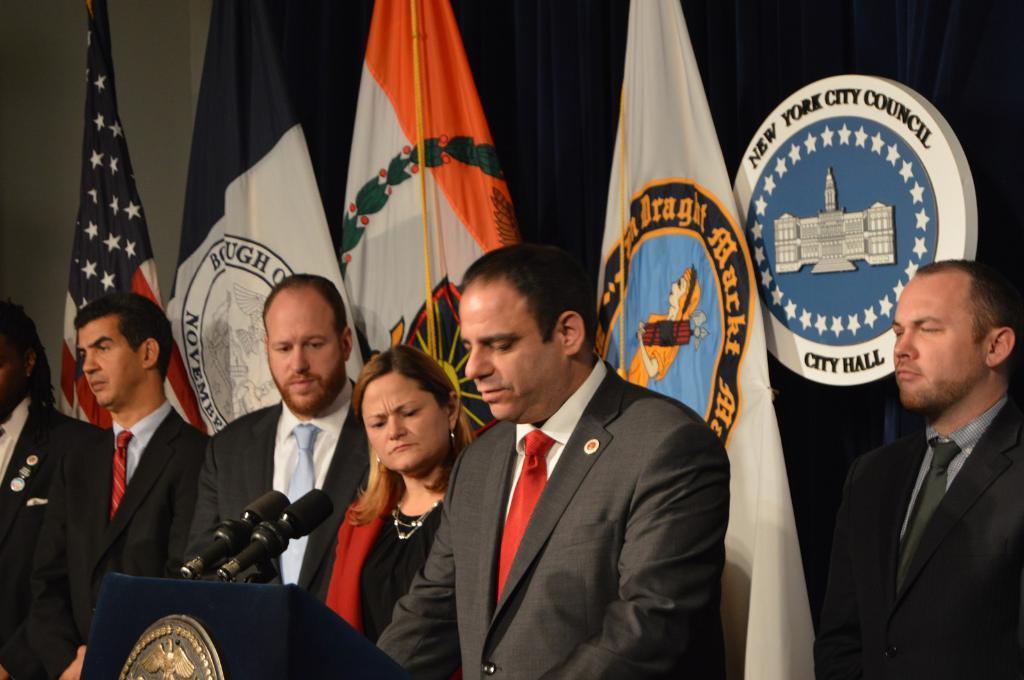Please provide a concise description of this image. In this image there are persons standing. In the front there is a podium and on the podium there are mics. In the background there are flags and there is a board with some text written on it and there is a curtain which is black in colour. 